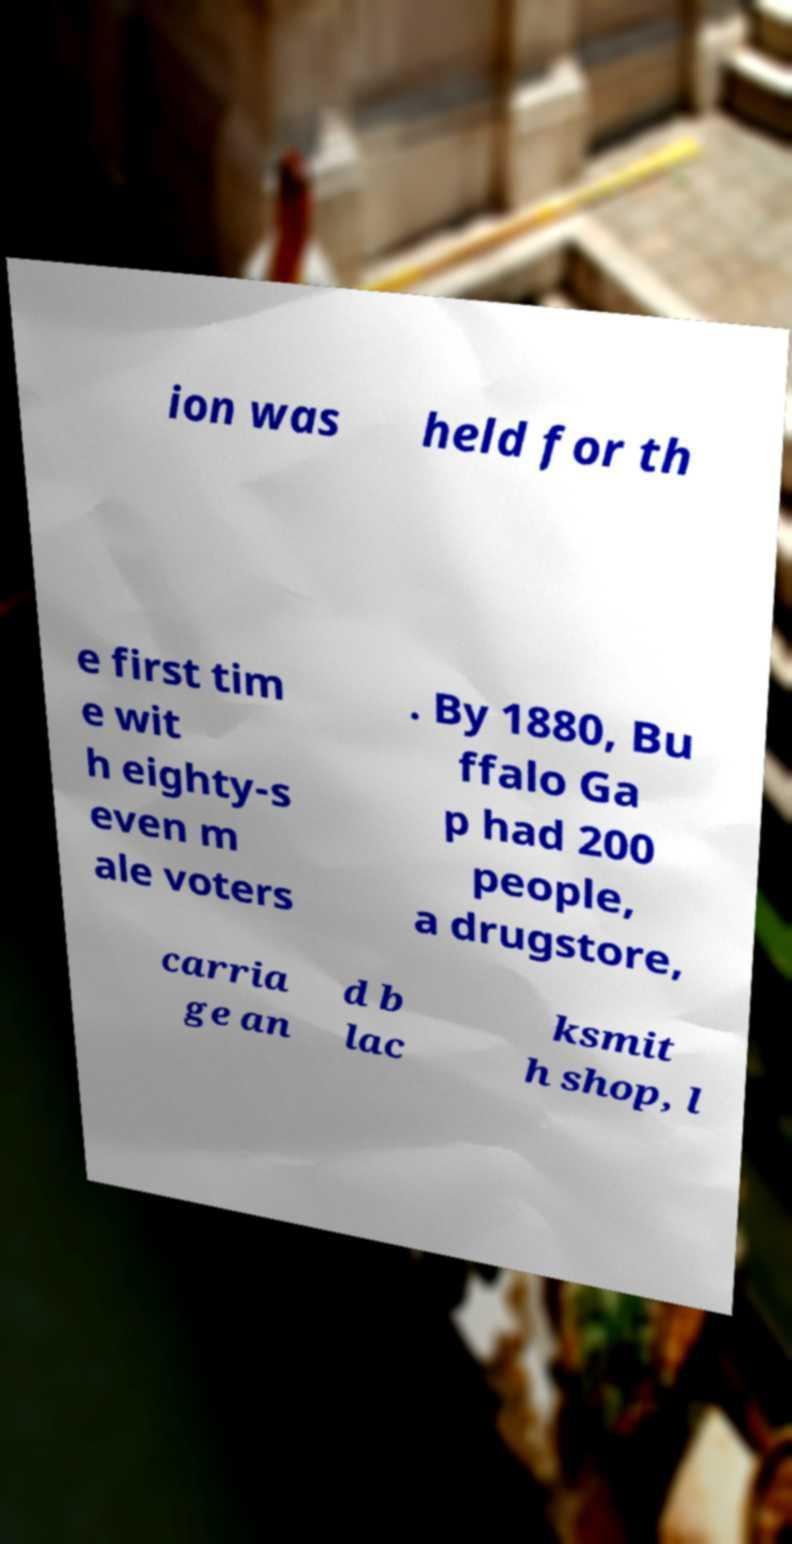Can you read and provide the text displayed in the image?This photo seems to have some interesting text. Can you extract and type it out for me? ion was held for th e first tim e wit h eighty-s even m ale voters . By 1880, Bu ffalo Ga p had 200 people, a drugstore, carria ge an d b lac ksmit h shop, l 